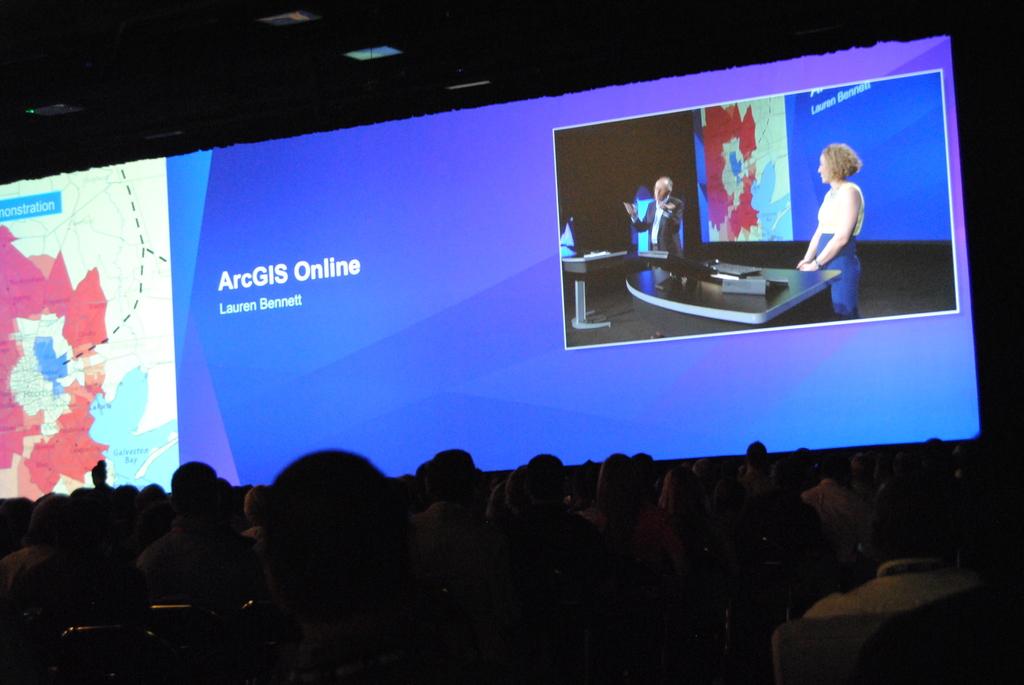What words are on the powerpoint presentation?
Make the answer very short. Arcgis online. Who authored the presentation?
Offer a very short reply. Lauren bennett. 